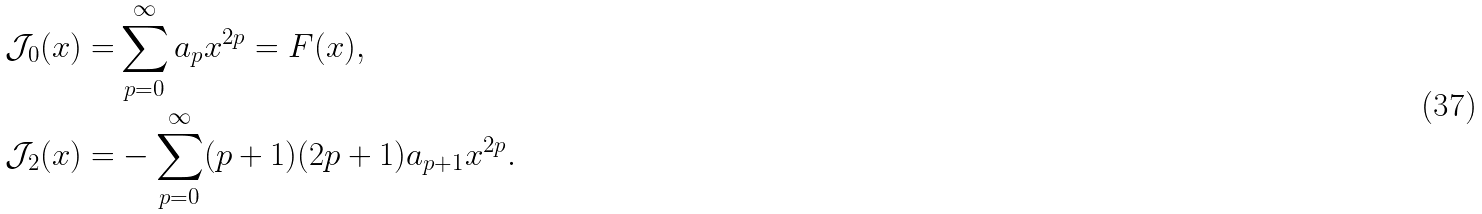<formula> <loc_0><loc_0><loc_500><loc_500>\mathcal { J } _ { 0 } ( x ) = & \sum _ { p = 0 } ^ { \infty } a _ { p } x ^ { 2 p } = F ( x ) , \\ \mathcal { J } _ { 2 } ( x ) = & - \sum _ { p = 0 } ^ { \infty } ( p + 1 ) ( 2 p + 1 ) a _ { p + 1 } x ^ { 2 p } .</formula> 